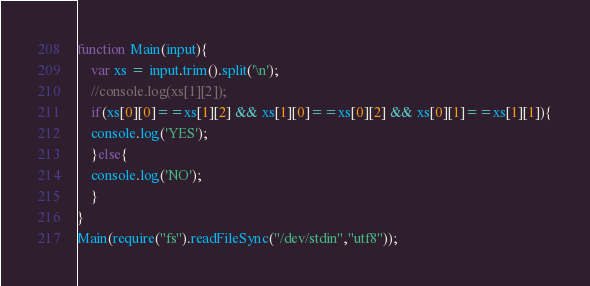Convert code to text. <code><loc_0><loc_0><loc_500><loc_500><_JavaScript_>function Main(input){
	var xs = input.trim().split('\n');
    //console.log(xs[1][2]);
    if(xs[0][0]==xs[1][2] && xs[1][0]==xs[0][2] && xs[0][1]==xs[1][1]){
    console.log('YES');
    }else{
    console.log('NO');
    }
}
Main(require("fs").readFileSync("/dev/stdin","utf8"));</code> 